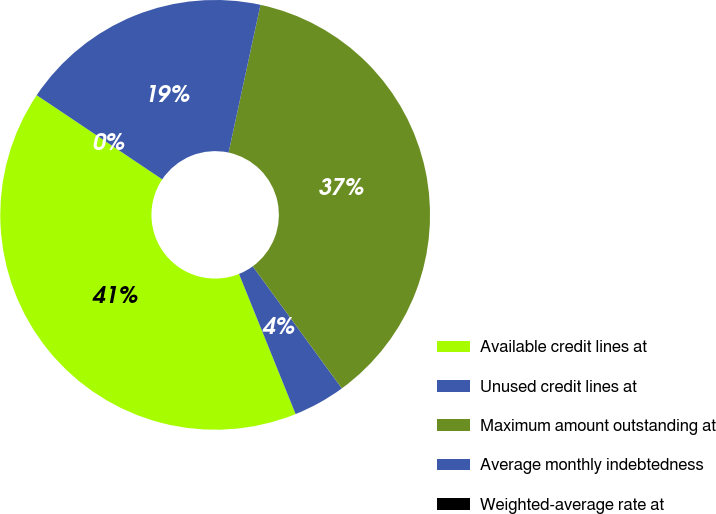Convert chart to OTSL. <chart><loc_0><loc_0><loc_500><loc_500><pie_chart><fcel>Available credit lines at<fcel>Unused credit lines at<fcel>Maximum amount outstanding at<fcel>Average monthly indebtedness<fcel>Weighted-average rate at<nl><fcel>40.51%<fcel>3.93%<fcel>36.58%<fcel>18.98%<fcel>0.0%<nl></chart> 